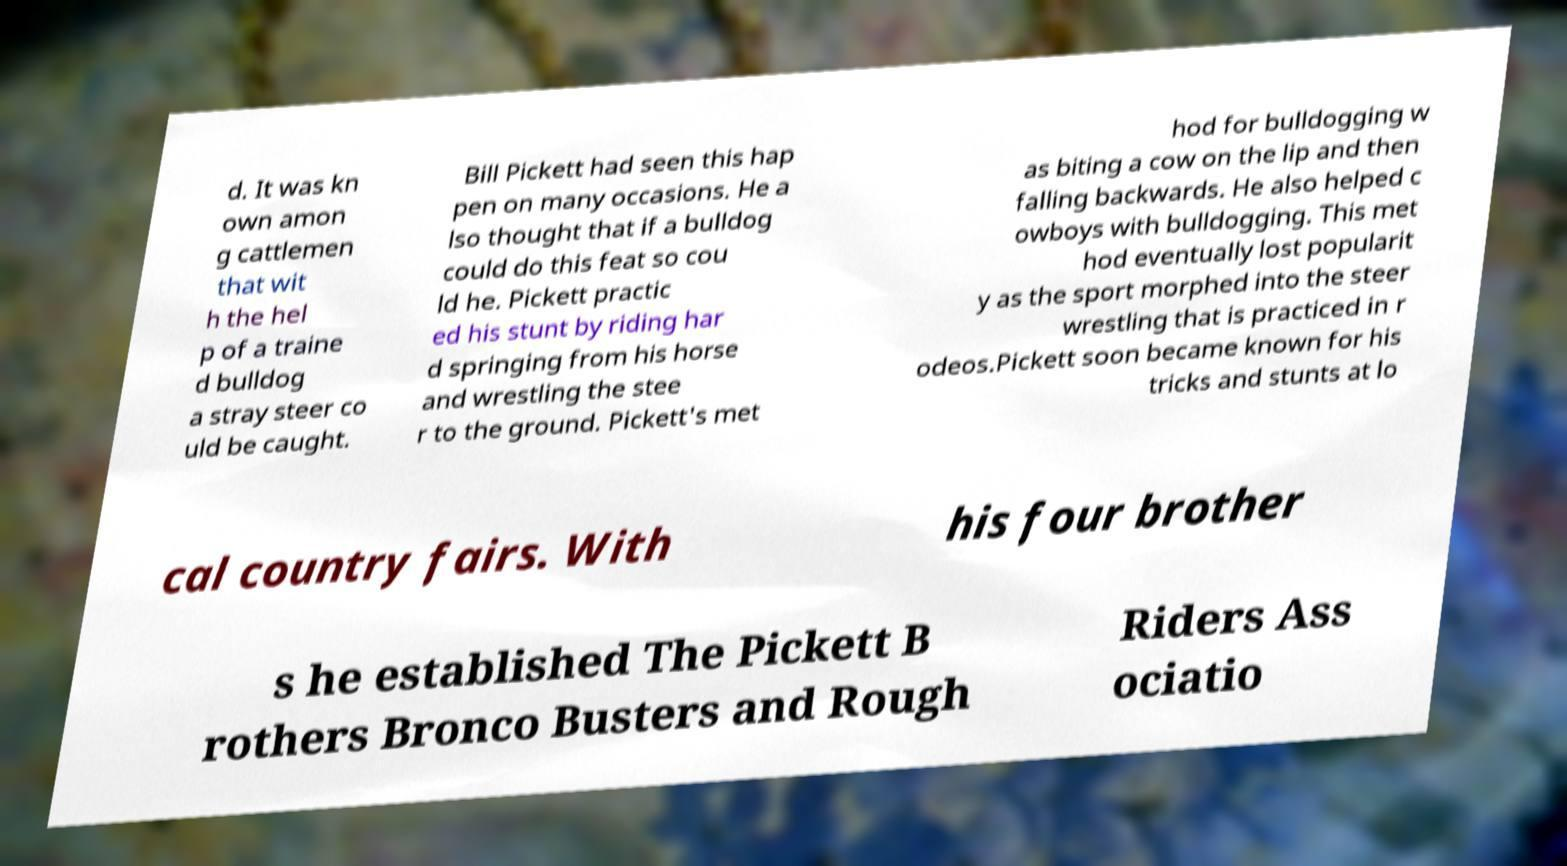Could you extract and type out the text from this image? d. It was kn own amon g cattlemen that wit h the hel p of a traine d bulldog a stray steer co uld be caught. Bill Pickett had seen this hap pen on many occasions. He a lso thought that if a bulldog could do this feat so cou ld he. Pickett practic ed his stunt by riding har d springing from his horse and wrestling the stee r to the ground. Pickett's met hod for bulldogging w as biting a cow on the lip and then falling backwards. He also helped c owboys with bulldogging. This met hod eventually lost popularit y as the sport morphed into the steer wrestling that is practiced in r odeos.Pickett soon became known for his tricks and stunts at lo cal country fairs. With his four brother s he established The Pickett B rothers Bronco Busters and Rough Riders Ass ociatio 